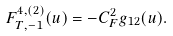Convert formula to latex. <formula><loc_0><loc_0><loc_500><loc_500>F _ { T , - 1 } ^ { 4 , ( 2 ) } ( u ) & = - C _ { F } ^ { 2 } g _ { 1 2 } ( u ) .</formula> 